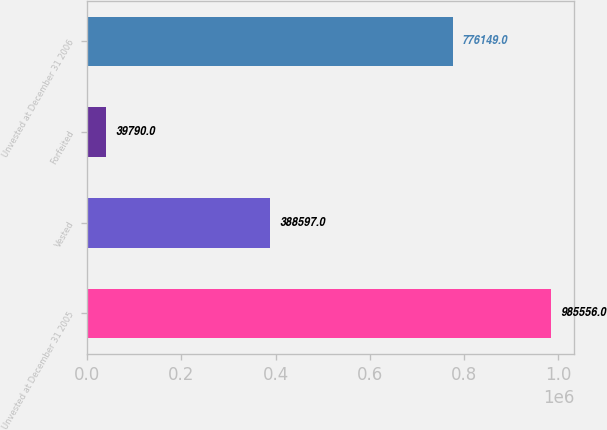Convert chart. <chart><loc_0><loc_0><loc_500><loc_500><bar_chart><fcel>Unvested at December 31 2005<fcel>Vested<fcel>Forfeited<fcel>Unvested at December 31 2006<nl><fcel>985556<fcel>388597<fcel>39790<fcel>776149<nl></chart> 